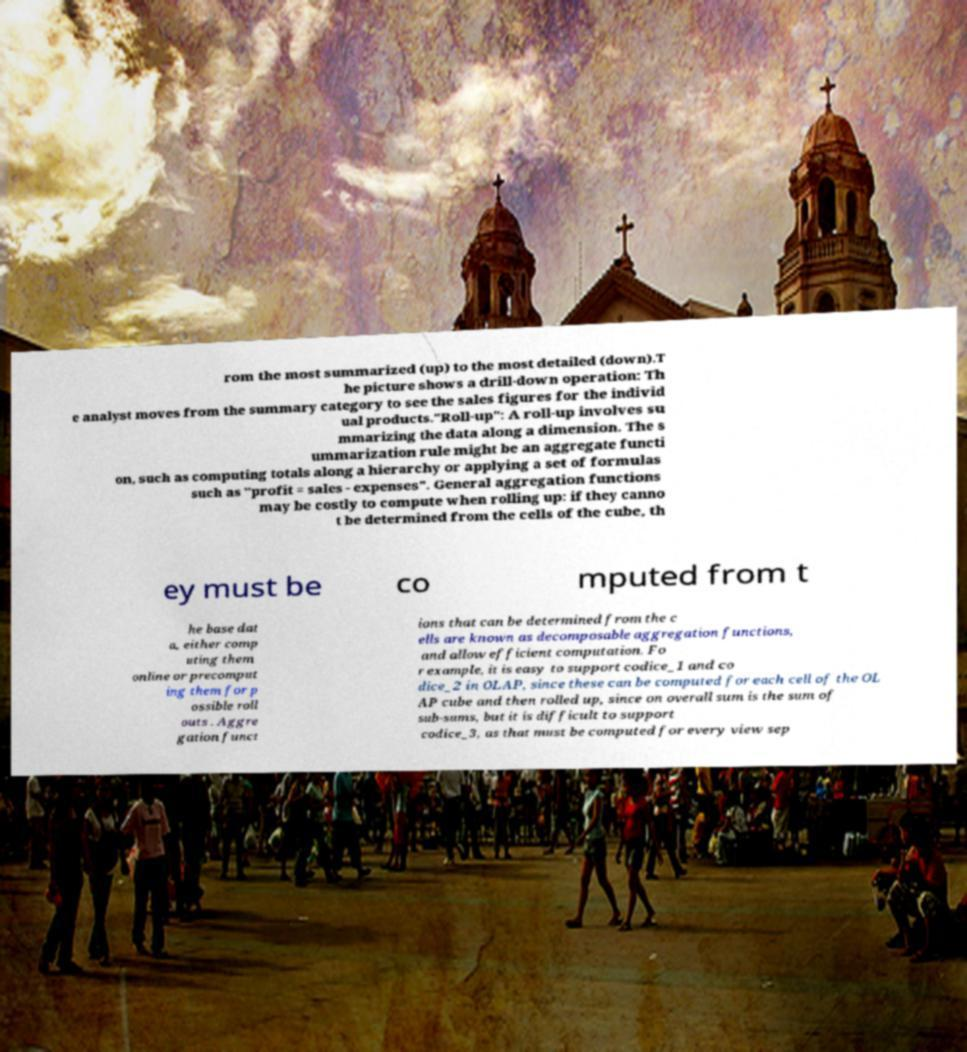Please read and relay the text visible in this image. What does it say? rom the most summarized (up) to the most detailed (down).T he picture shows a drill-down operation: Th e analyst moves from the summary category to see the sales figures for the individ ual products."Roll-up": A roll-up involves su mmarizing the data along a dimension. The s ummarization rule might be an aggregate functi on, such as computing totals along a hierarchy or applying a set of formulas such as "profit = sales - expenses". General aggregation functions may be costly to compute when rolling up: if they canno t be determined from the cells of the cube, th ey must be co mputed from t he base dat a, either comp uting them online or precomput ing them for p ossible roll outs . Aggre gation funct ions that can be determined from the c ells are known as decomposable aggregation functions, and allow efficient computation. Fo r example, it is easy to support codice_1 and co dice_2 in OLAP, since these can be computed for each cell of the OL AP cube and then rolled up, since on overall sum is the sum of sub-sums, but it is difficult to support codice_3, as that must be computed for every view sep 